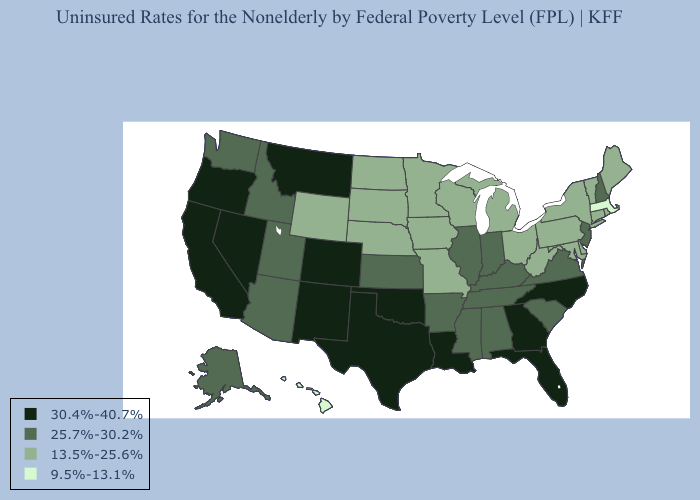What is the value of California?
Keep it brief. 30.4%-40.7%. Does South Dakota have a lower value than New York?
Be succinct. No. Name the states that have a value in the range 9.5%-13.1%?
Short answer required. Hawaii, Massachusetts. Does Massachusetts have the lowest value in the USA?
Concise answer only. Yes. Does Massachusetts have the lowest value in the Northeast?
Give a very brief answer. Yes. What is the value of Mississippi?
Be succinct. 25.7%-30.2%. Which states have the highest value in the USA?
Quick response, please. California, Colorado, Florida, Georgia, Louisiana, Montana, Nevada, New Mexico, North Carolina, Oklahoma, Oregon, Texas. Does Illinois have the lowest value in the USA?
Concise answer only. No. Does Oklahoma have the highest value in the USA?
Give a very brief answer. Yes. Among the states that border Connecticut , which have the lowest value?
Quick response, please. Massachusetts. Does Oklahoma have the same value as Nevada?
Keep it brief. Yes. What is the value of Oklahoma?
Keep it brief. 30.4%-40.7%. What is the value of Michigan?
Be succinct. 13.5%-25.6%. Among the states that border Connecticut , which have the lowest value?
Give a very brief answer. Massachusetts. Name the states that have a value in the range 25.7%-30.2%?
Be succinct. Alabama, Alaska, Arizona, Arkansas, Idaho, Illinois, Indiana, Kansas, Kentucky, Mississippi, New Hampshire, New Jersey, South Carolina, Tennessee, Utah, Virginia, Washington. 